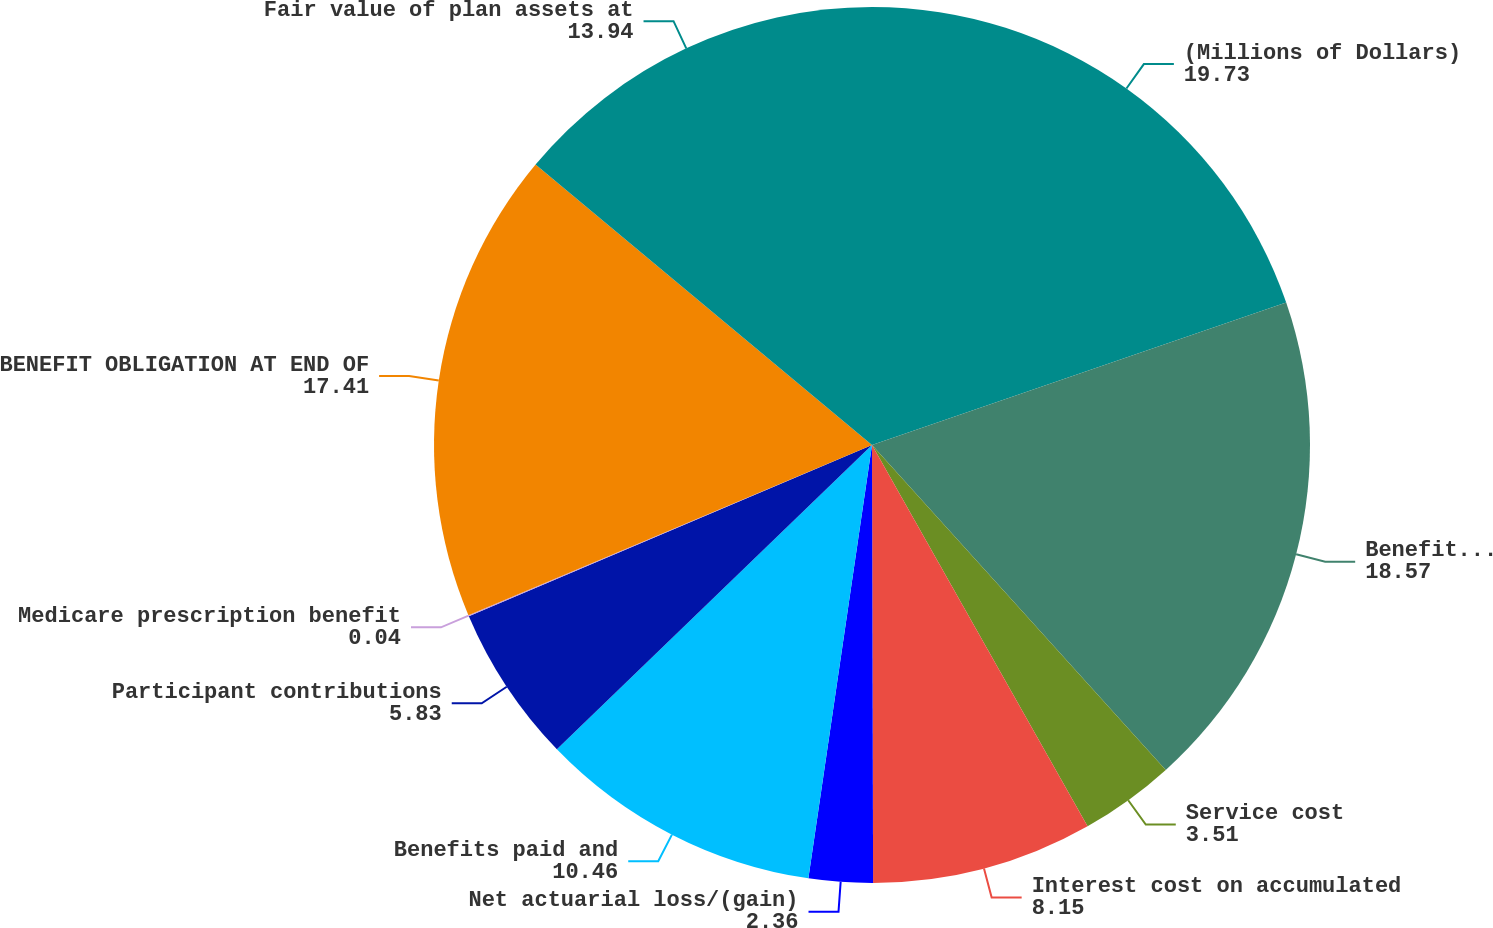Convert chart to OTSL. <chart><loc_0><loc_0><loc_500><loc_500><pie_chart><fcel>(Millions of Dollars)<fcel>Benefit obligation at<fcel>Service cost<fcel>Interest cost on accumulated<fcel>Net actuarial loss/(gain)<fcel>Benefits paid and<fcel>Participant contributions<fcel>Medicare prescription benefit<fcel>BENEFIT OBLIGATION AT END OF<fcel>Fair value of plan assets at<nl><fcel>19.73%<fcel>18.57%<fcel>3.51%<fcel>8.15%<fcel>2.36%<fcel>10.46%<fcel>5.83%<fcel>0.04%<fcel>17.41%<fcel>13.94%<nl></chart> 